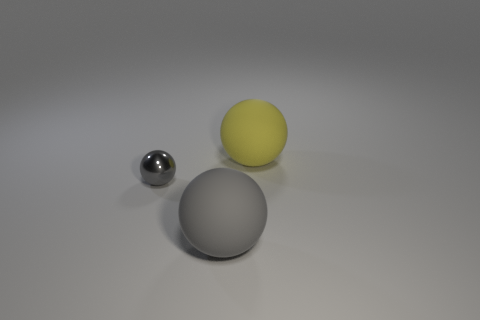Add 2 big blue shiny things. How many objects exist? 5 Add 3 small gray metal things. How many small gray metal things are left? 4 Add 2 gray balls. How many gray balls exist? 4 Subtract 0 green blocks. How many objects are left? 3 Subtract all blue spheres. Subtract all gray spheres. How many objects are left? 1 